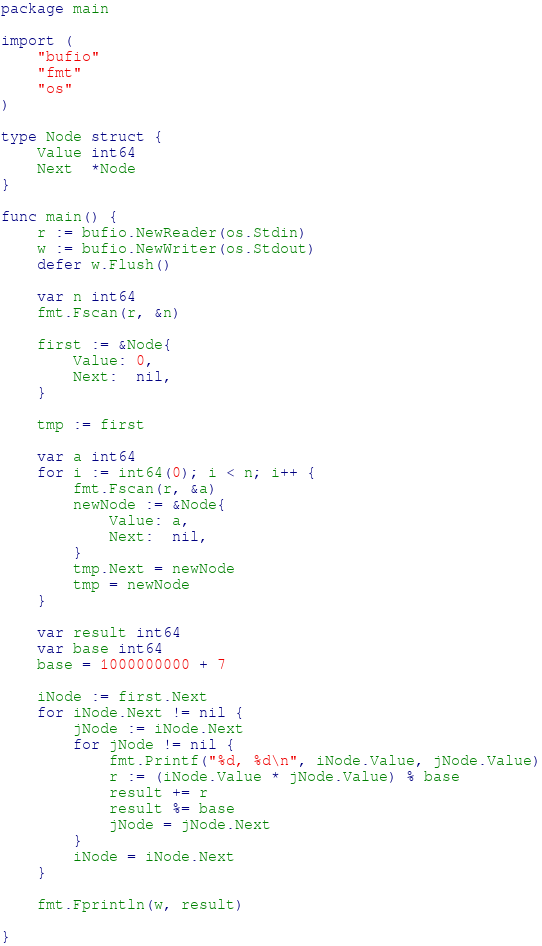<code> <loc_0><loc_0><loc_500><loc_500><_Go_>package main

import (
	"bufio"
	"fmt"
	"os"
)

type Node struct {
	Value int64
	Next  *Node
}

func main() {
	r := bufio.NewReader(os.Stdin)
	w := bufio.NewWriter(os.Stdout)
	defer w.Flush()

	var n int64
	fmt.Fscan(r, &n)

	first := &Node{
		Value: 0,
		Next:  nil,
	}

	tmp := first

	var a int64
	for i := int64(0); i < n; i++ {
		fmt.Fscan(r, &a)
		newNode := &Node{
			Value: a,
			Next:  nil,
		}
		tmp.Next = newNode
		tmp = newNode
	}

	var result int64
	var base int64
	base = 1000000000 + 7

	iNode := first.Next
	for iNode.Next != nil {
		jNode := iNode.Next
		for jNode != nil {
			fmt.Printf("%d, %d\n", iNode.Value, jNode.Value)
			r := (iNode.Value * jNode.Value) % base
			result += r
			result %= base
			jNode = jNode.Next
		}
		iNode = iNode.Next
	}

	fmt.Fprintln(w, result)

}
</code> 